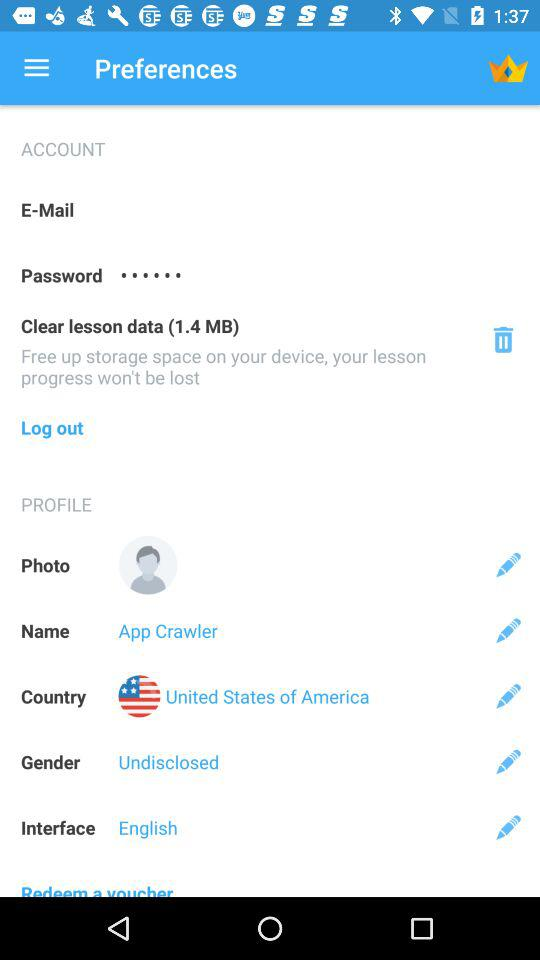What is entered in the "Gender"? The term entered in "Gender" is "Undisclosed". 